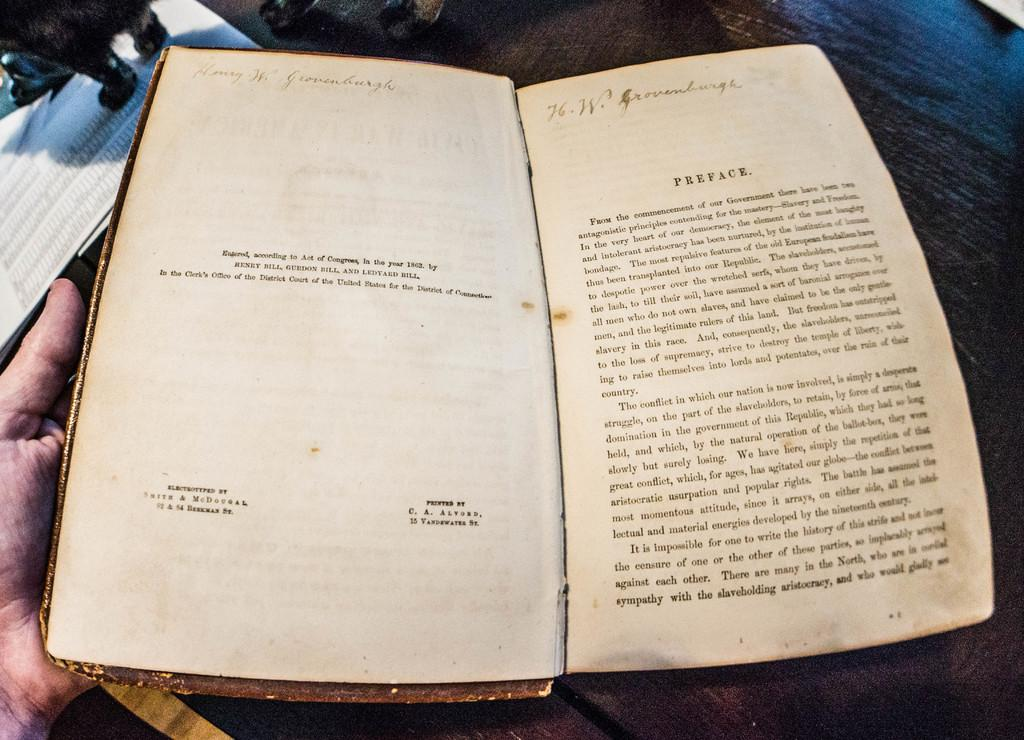<image>
Create a compact narrative representing the image presented. An aged book with yellowing pages is opened to the preface page. 